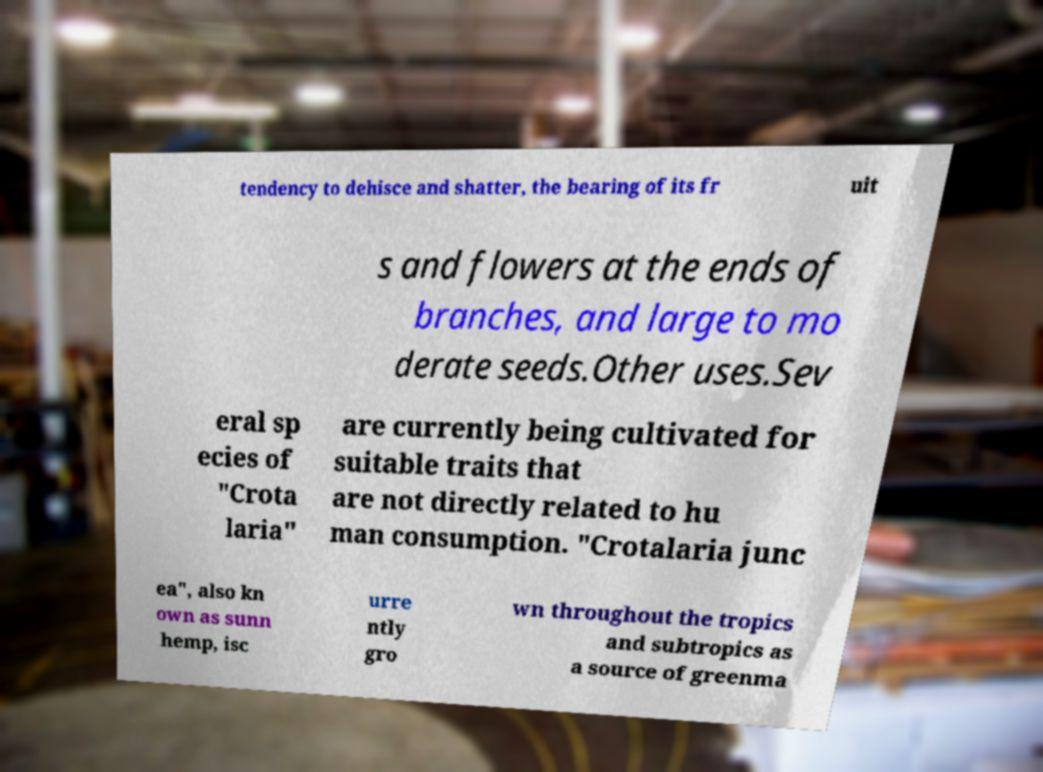Could you assist in decoding the text presented in this image and type it out clearly? tendency to dehisce and shatter, the bearing of its fr uit s and flowers at the ends of branches, and large to mo derate seeds.Other uses.Sev eral sp ecies of "Crota laria" are currently being cultivated for suitable traits that are not directly related to hu man consumption. "Crotalaria junc ea", also kn own as sunn hemp, isc urre ntly gro wn throughout the tropics and subtropics as a source of greenma 